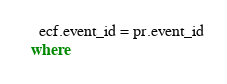Convert code to text. <code><loc_0><loc_0><loc_500><loc_500><_SQL_>    ecf.event_id = pr.event_id
  where</code> 